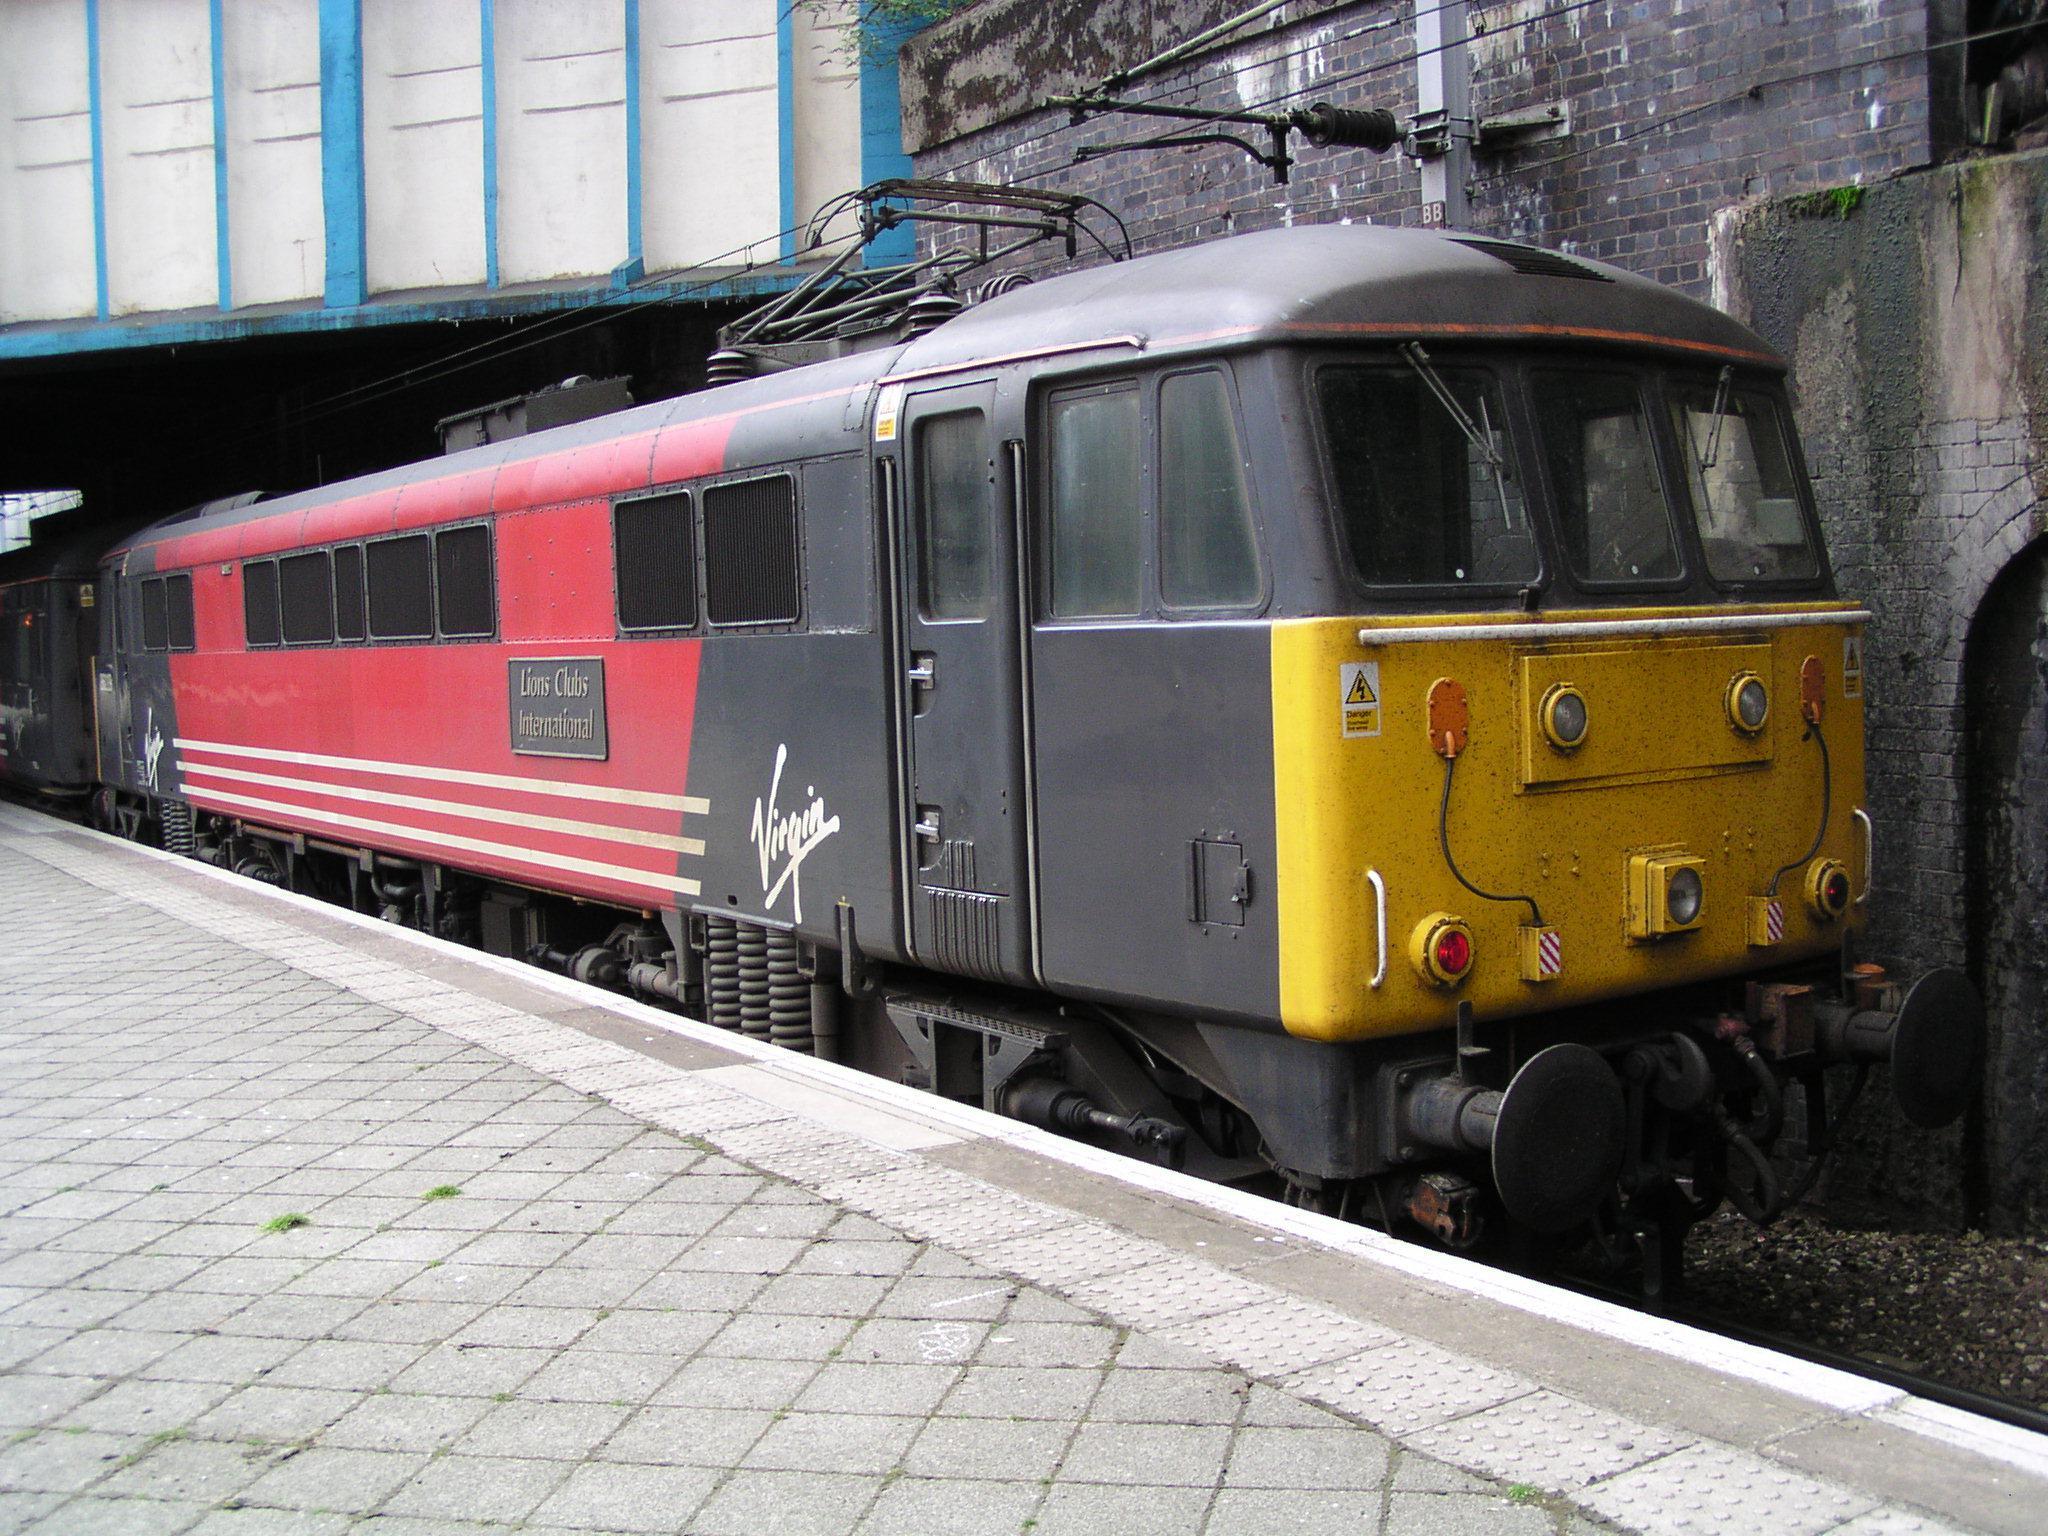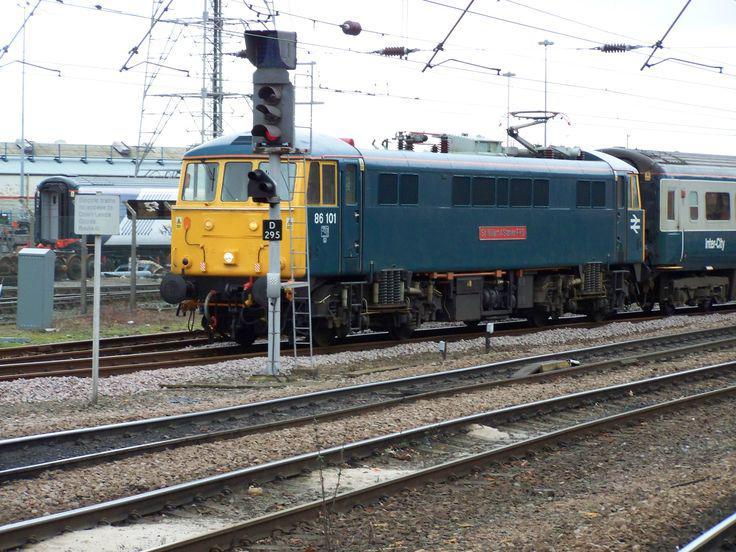The first image is the image on the left, the second image is the image on the right. For the images shown, is this caption "The train in the right image is painted yellow in the front." true? Answer yes or no. Yes. The first image is the image on the left, the second image is the image on the right. Analyze the images presented: Is the assertion "The train in one of the images has just come around a bend." valid? Answer yes or no. No. 